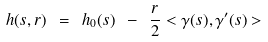<formula> <loc_0><loc_0><loc_500><loc_500>h ( s , r ) \ = \ h _ { 0 } ( s ) \ - \ \frac { r } { 2 } < \gamma ( s ) , \gamma ^ { \prime } ( s ) > \</formula> 